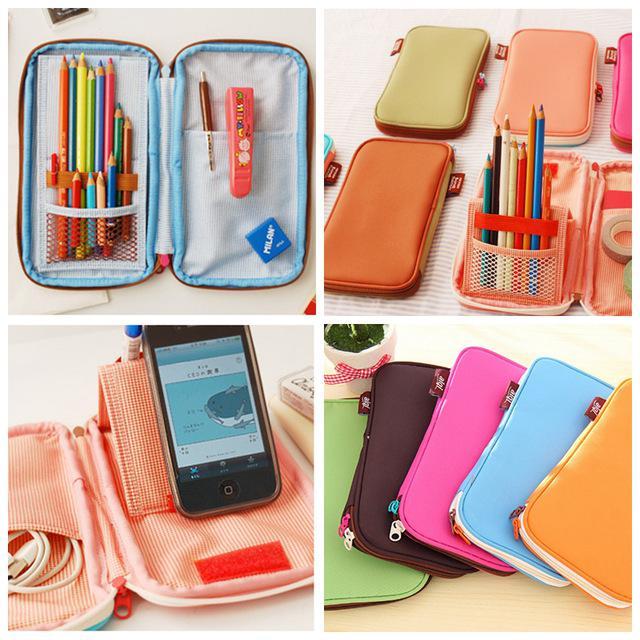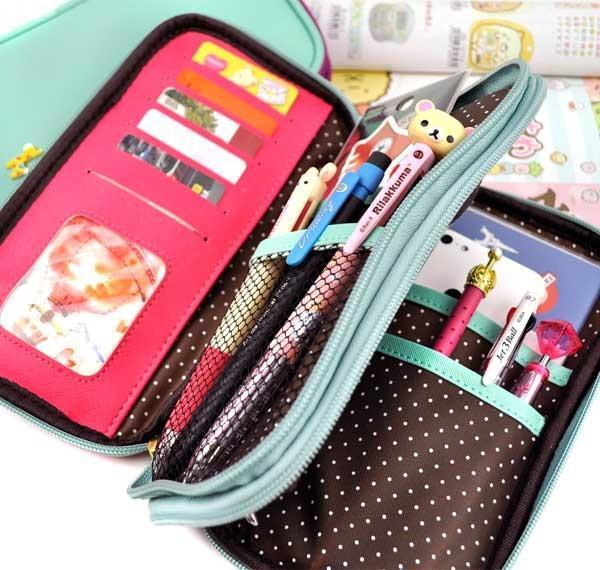The first image is the image on the left, the second image is the image on the right. For the images shown, is this caption "There is a human hand touching a pencil case in one of the images." true? Answer yes or no. No. 